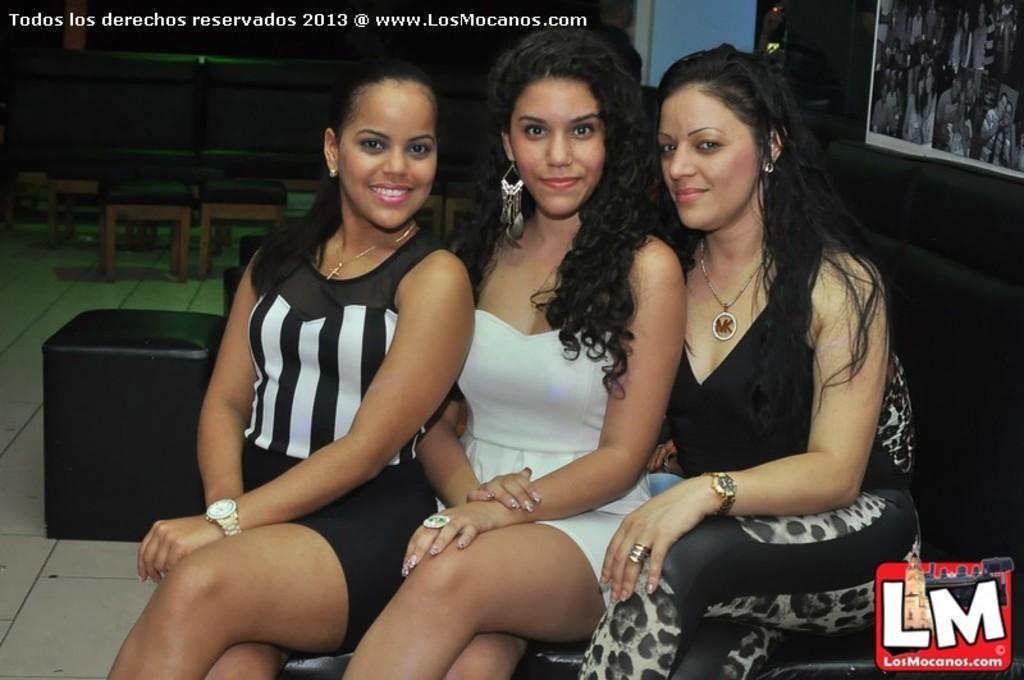Describe this image in one or two sentences. In this image there are three persons sitting on the sofa. Behind them there is a couch. There are chairs. On the right side of the image there is a poster on the wall. There is some text on the top of the image. There is a logo on the right side of the image. At the bottom of the image there is a floor. 